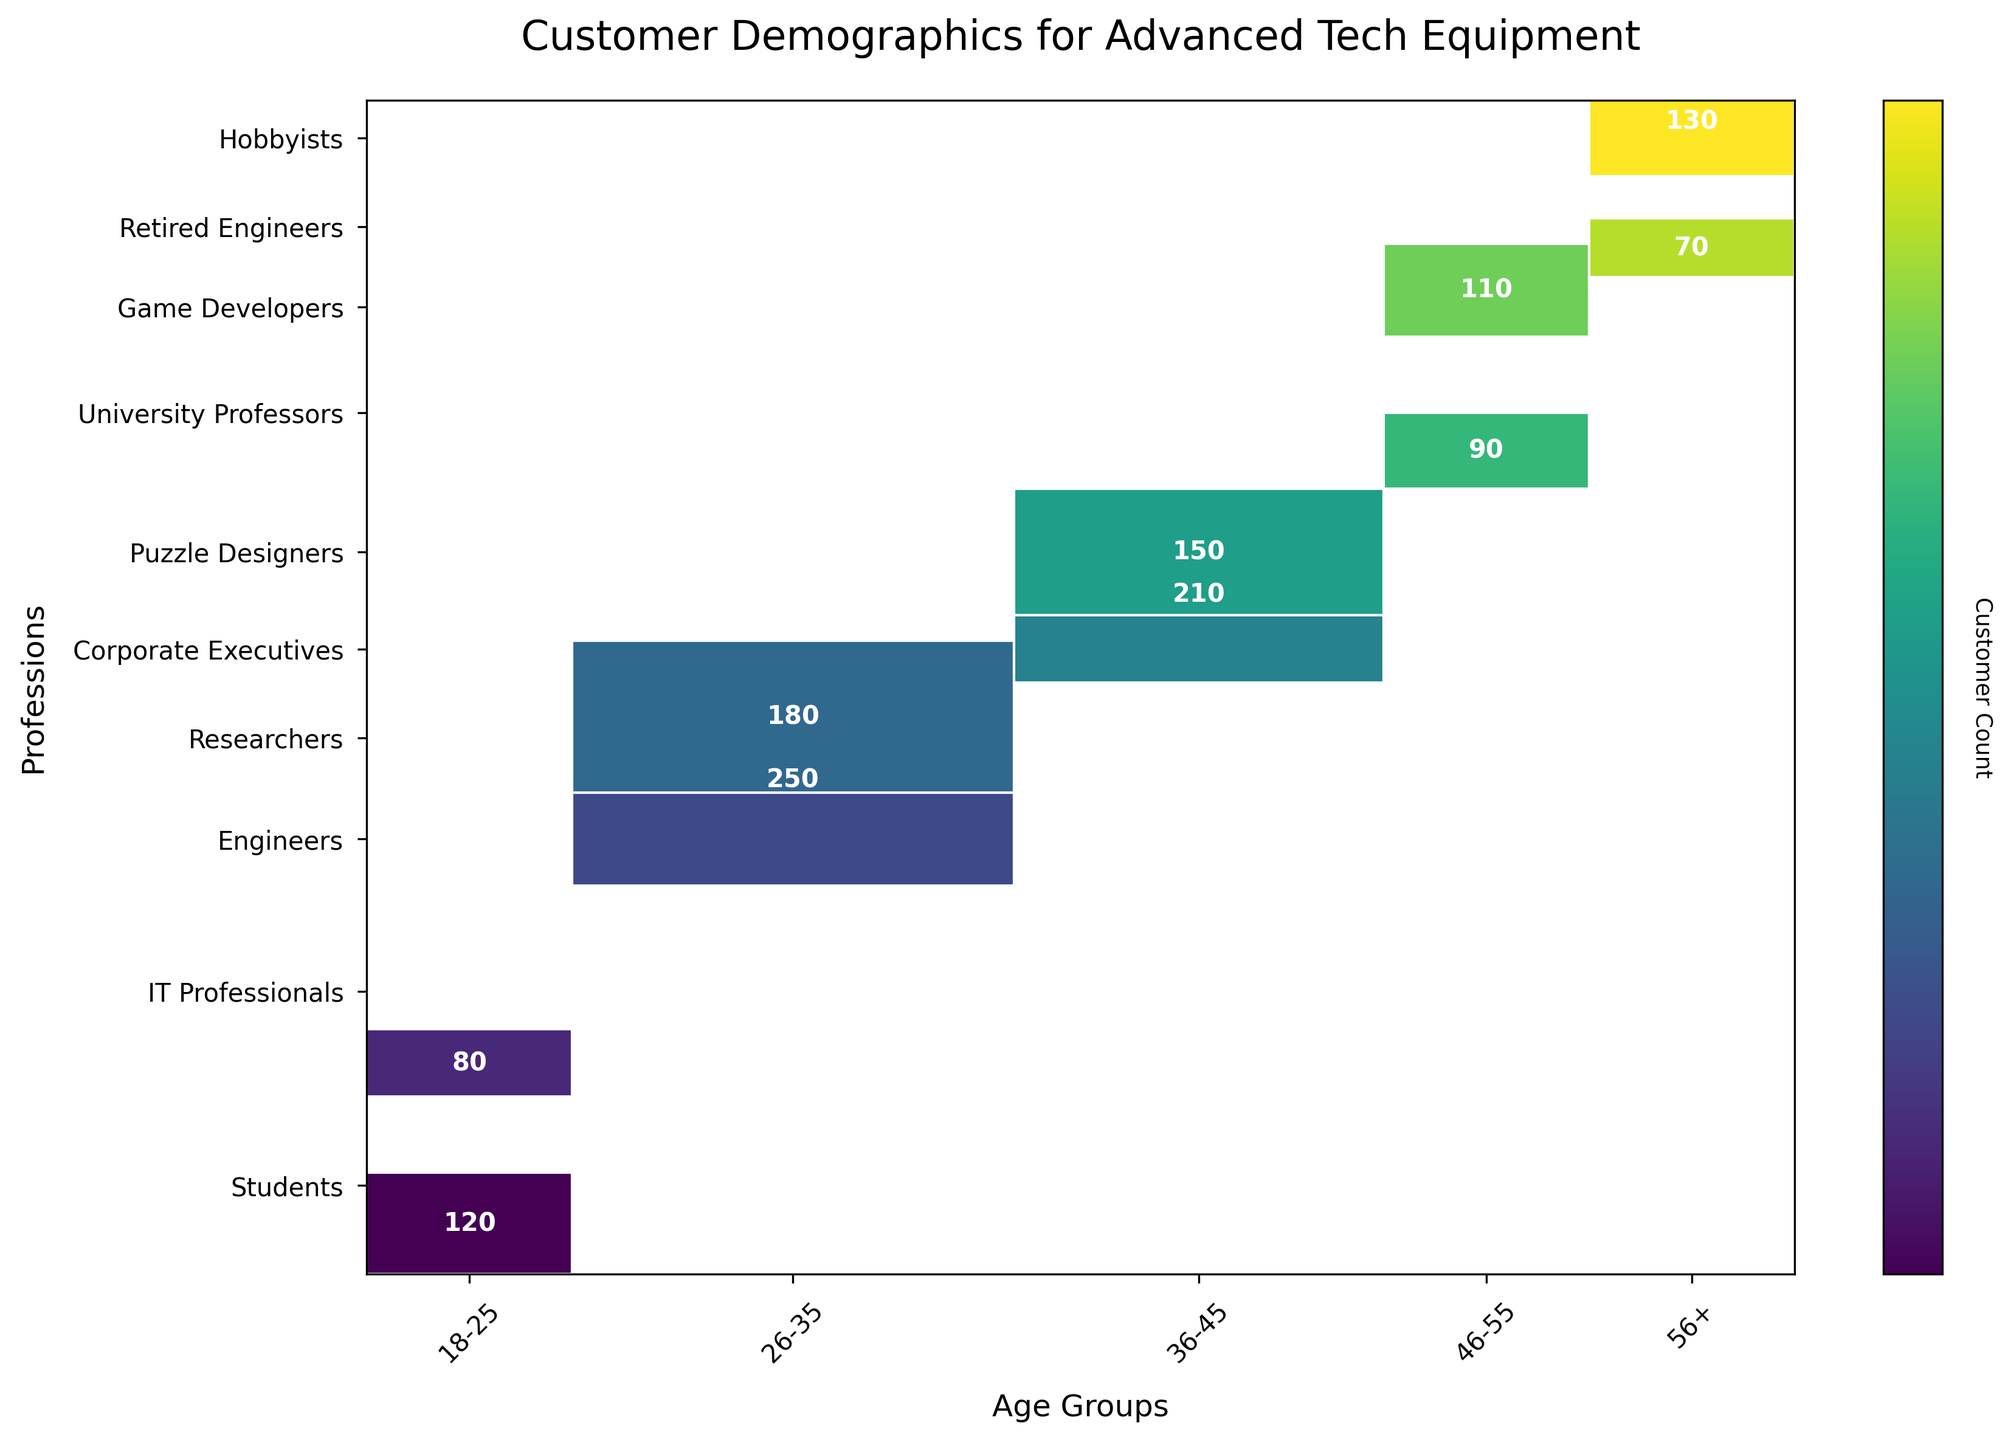What's the title of the mosaic plot? The title is usually displayed at the top of the figure.
Answer: Customer Demographics for Advanced Tech Equipment What is the age group with the most customers? By looking at the mosaic plot, we can see that the width of each age group’s section along the x-axis represents the total number of customers in that age group. The widest section indicates the age group with the most customers.
Answer: 26-35 How many customers are there in the 56+ age group who are Hobbyists? Find the intersecting cell between the "56+" age group (x-axis) and "Hobbyists" profession (y-axis) and noted the number displayed within this cell.
Answer: 130 Which profession has the fewest customers in the 46-55 age group? Identify the columns corresponding to the "46-55" age group and see which cell has the smallest area or the smallest count within it when compared to other professions in that age group.
Answer: University Professors What is the total number of students across all age groups? Find each cell corresponding to "Students" on the y-axis and sum all the values displayed within those cells to get the total.
Answer: 120 How does the number of IT Professionals in the 18-25 age group compare to the number of Game Developers in the 46-55 age group? Identify the intersecting cells for "18-25" age group and "IT Professionals" and "46-55" age group and "Game Developers", then compare the values directly.
Answer: 80 (IT Professionals) is less than 110 (Game Developers) Which profession in the 26-35 age group has more customers: Engineers or Researchers? Locate the intersecting cells for "26-35" age group with "Engineers" and "Researchers," then compare the numbers displayed within those cells.
Answer: Engineers What is the sum of customers across all professions within the 36-45 age group? Sum the customer counts for each cell within the "36-45" age group column: 210 (Corporate Executives) + 150 (Puzzle Designers).
Answer: 360 How many professions are represented on the y-axis of the mosaic plot? Count each unique label along the y-axis, which represents different professions.
Answer: 10 